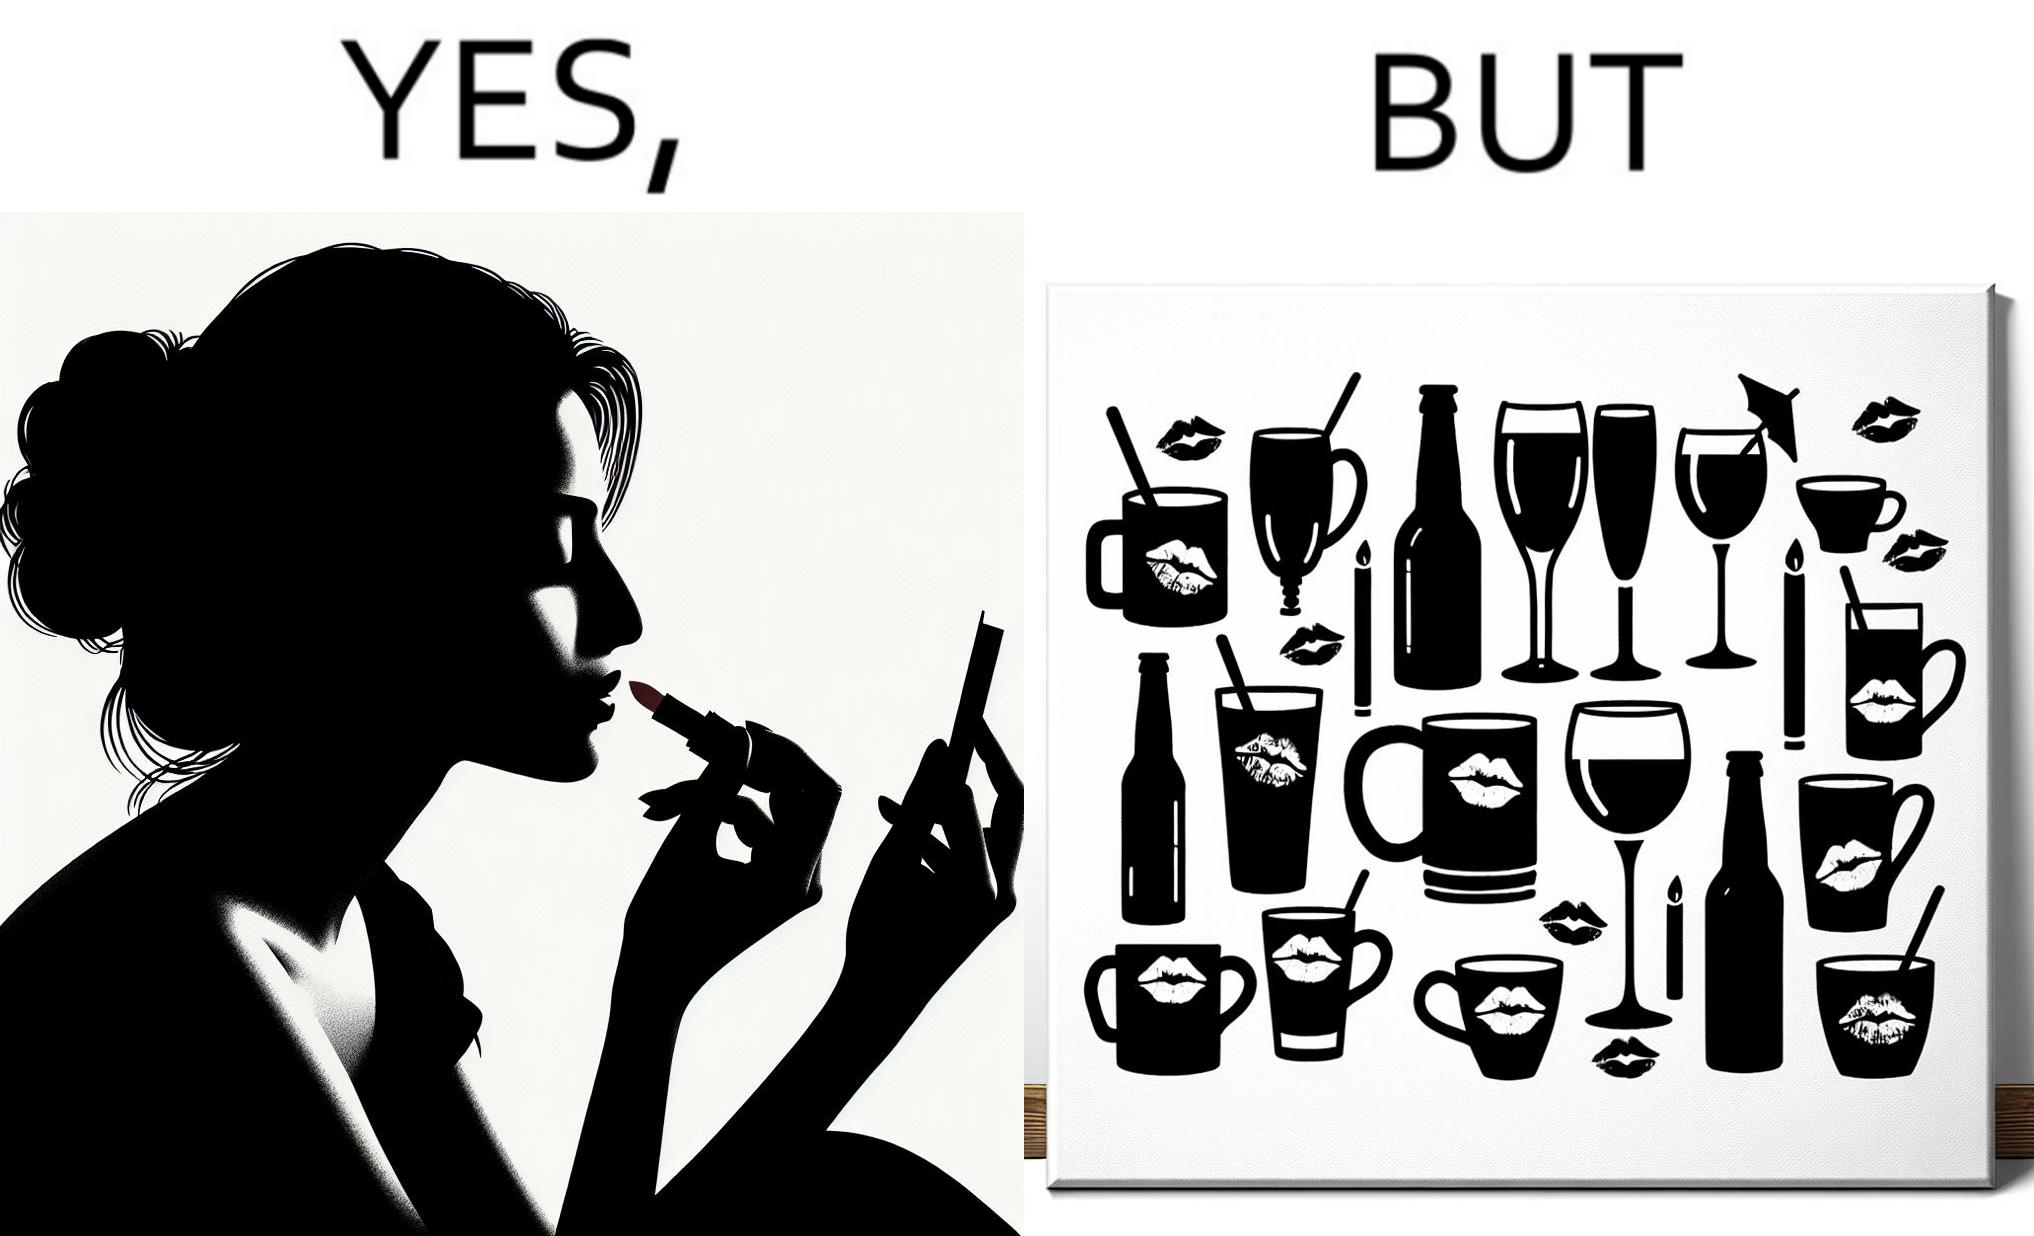Compare the left and right sides of this image. In the left part of the image: a person applying lipstick, probably a girl or woman In the right part of the image: lipstick stains on various mugs and glasses 